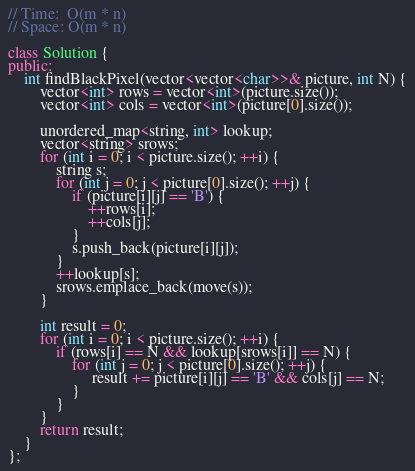<code> <loc_0><loc_0><loc_500><loc_500><_C++_>// Time:  O(m * n)
// Space: O(m * n)

class Solution {
public:
    int findBlackPixel(vector<vector<char>>& picture, int N) {
        vector<int> rows = vector<int>(picture.size());
        vector<int> cols = vector<int>(picture[0].size());

        unordered_map<string, int> lookup;
        vector<string> srows;
        for (int i = 0; i < picture.size(); ++i) {
            string s;
            for (int j = 0; j < picture[0].size(); ++j) {
                if (picture[i][j] == 'B') {
                    ++rows[i];
                    ++cols[j];
                }
                s.push_back(picture[i][j]);
            }
            ++lookup[s];
            srows.emplace_back(move(s));
        }

        int result = 0;
        for (int i = 0; i < picture.size(); ++i) {
            if (rows[i] == N && lookup[srows[i]] == N) {
                for (int j = 0; j < picture[0].size(); ++j) {
                     result += picture[i][j] == 'B' && cols[j] == N;
                }
            }
        }
        return result;
    }
};
</code> 